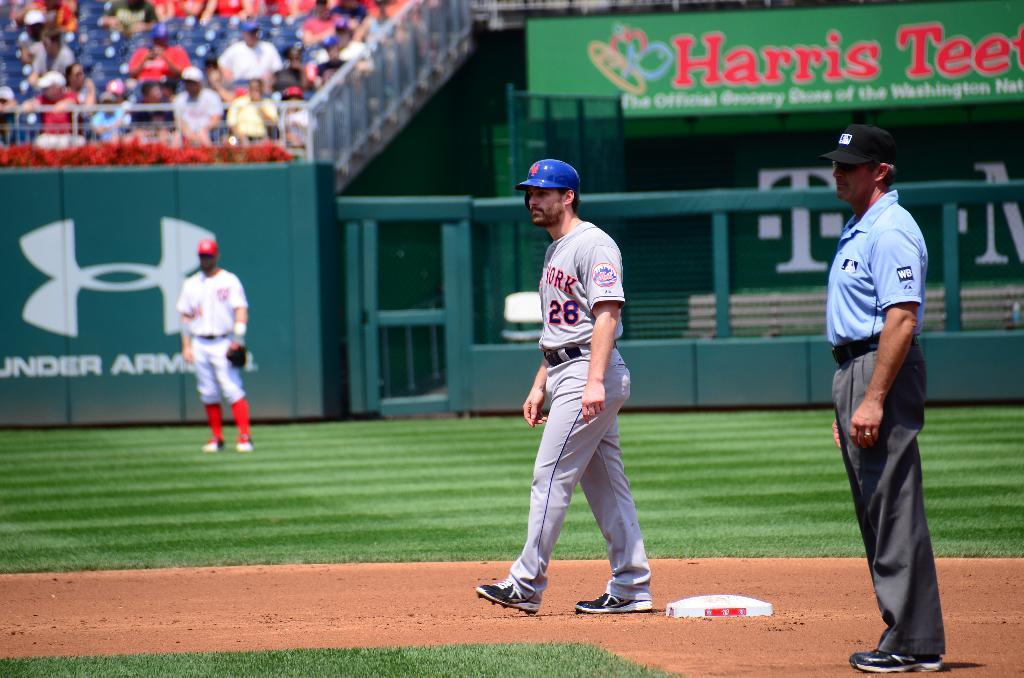<image>
Describe the image concisely. the word Harris is on the sign in the outfield 